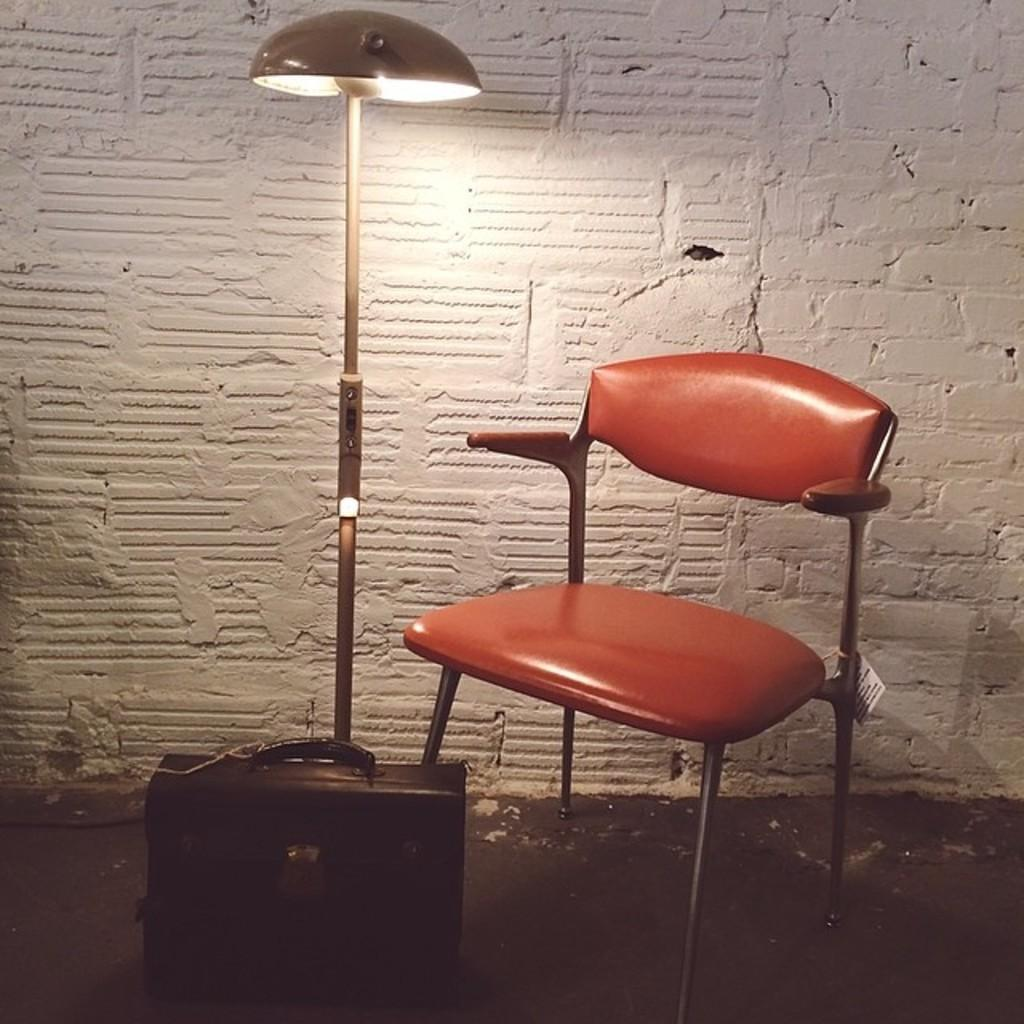What type of furniture is in the image? There is a chair in the image. What object is typically used for carrying belongings and is present in the image? There is a suitcase in the image. What is the source of light in the image? There is a lamp in the image. What color is the wall visible in the background of the image? There is a white wall in the background of the image. How many women are wearing skirts in the image? There are no women present in the image, so it is not possible to determine the number of women wearing skirts. 